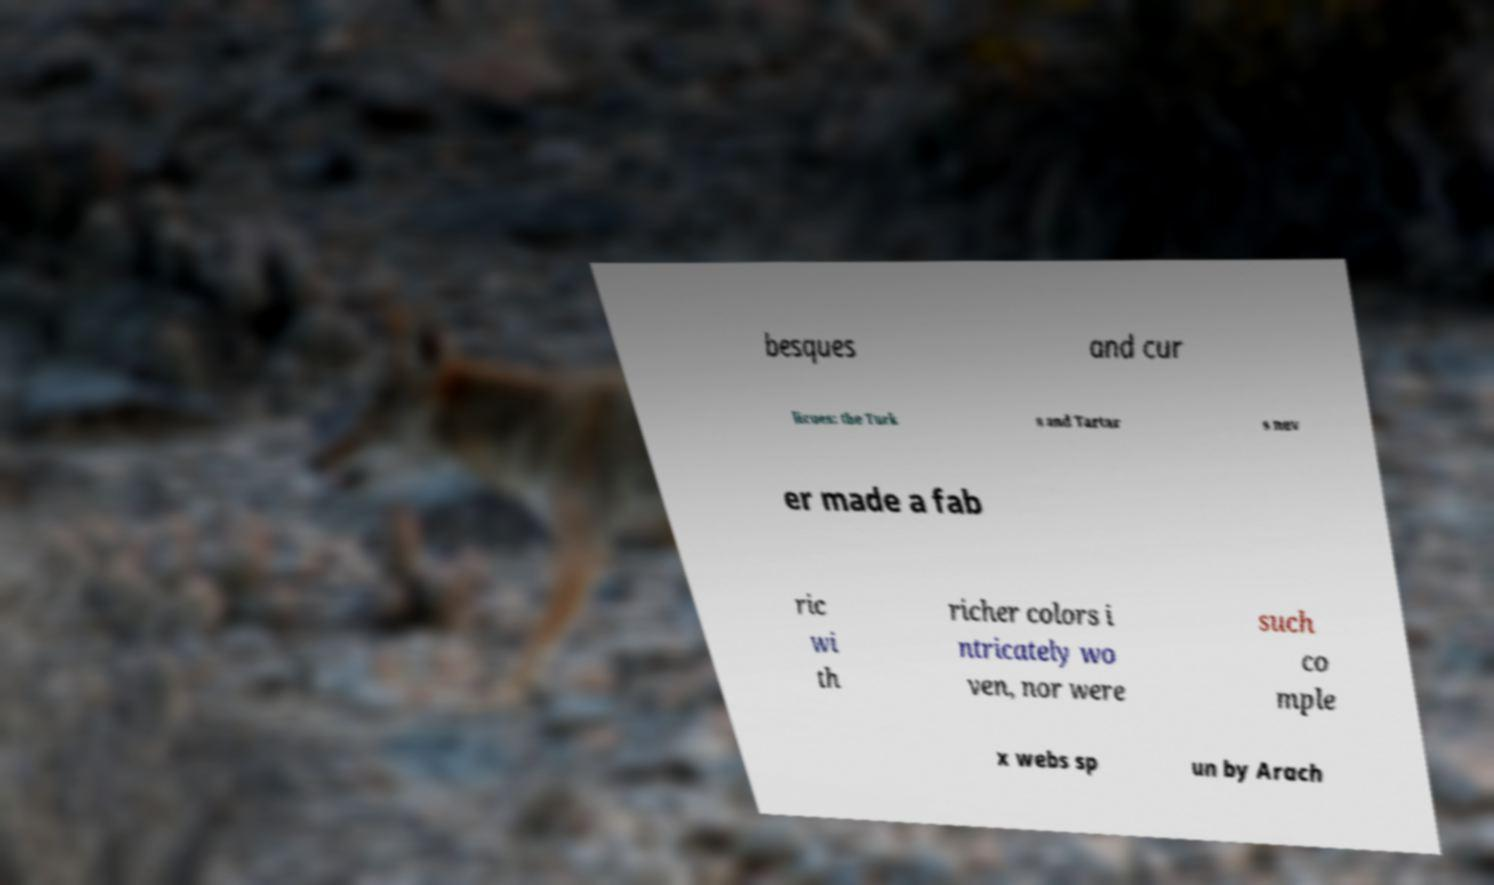Can you accurately transcribe the text from the provided image for me? besques and cur licues: the Turk s and Tartar s nev er made a fab ric wi th richer colors i ntricately wo ven, nor were such co mple x webs sp un by Arach 